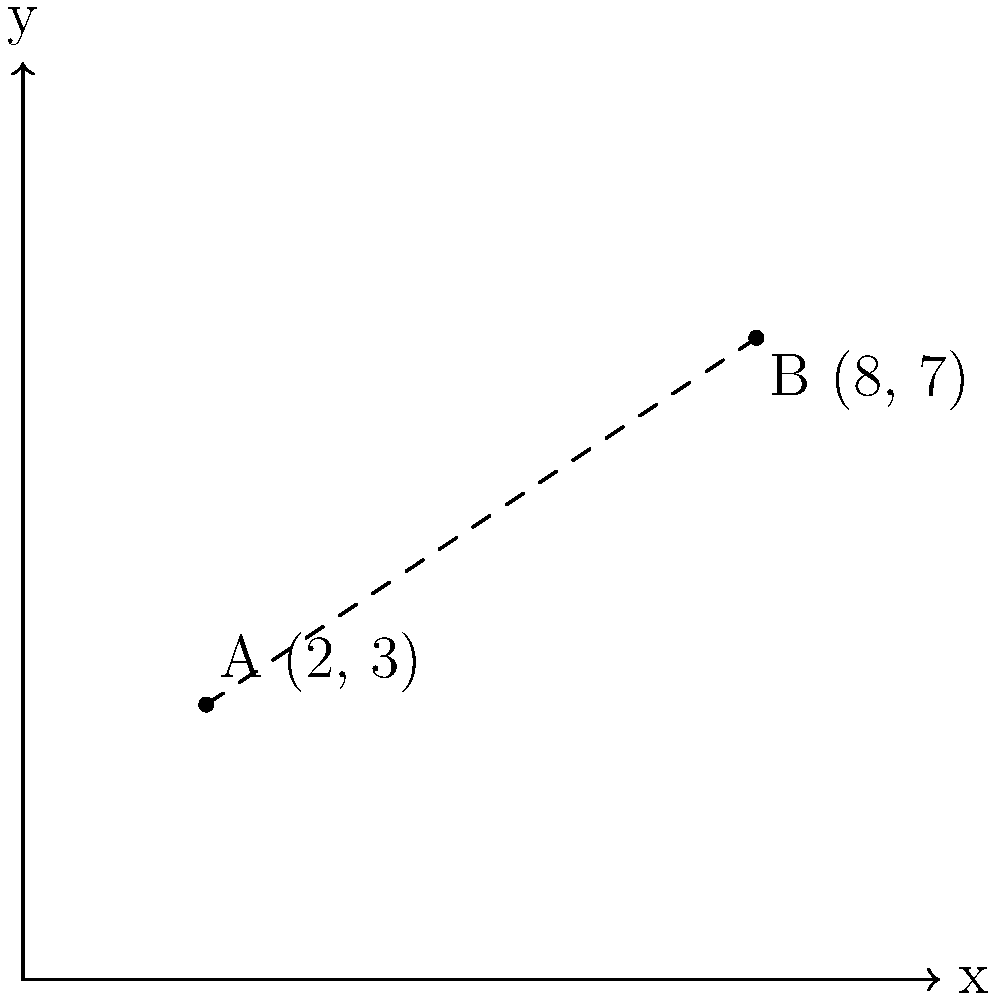As a logistician managing relief goods distribution, you need to calculate the distance between two distribution points on a map. Point A has coordinates (2, 3) and Point B has coordinates (8, 7). Using the distance formula, calculate the straight-line distance between these two points. Round your answer to two decimal places. To find the distance between two points given their coordinates, we can use the distance formula:

$$ d = \sqrt{(x_2 - x_1)^2 + (y_2 - y_1)^2} $$

Where $(x_1, y_1)$ are the coordinates of the first point and $(x_2, y_2)$ are the coordinates of the second point.

Given:
Point A: $(x_1, y_1) = (2, 3)$
Point B: $(x_2, y_2) = (8, 7)$

Step 1: Substitute the values into the formula.
$$ d = \sqrt{(8 - 2)^2 + (7 - 3)^2} $$

Step 2: Simplify the expressions inside the parentheses.
$$ d = \sqrt{6^2 + 4^2} $$

Step 3: Calculate the squares.
$$ d = \sqrt{36 + 16} $$

Step 4: Add the values under the square root.
$$ d = \sqrt{52} $$

Step 5: Calculate the square root and round to two decimal places.
$$ d \approx 7.21 $$

Therefore, the distance between the two distribution points is approximately 7.21 units on the map.
Answer: 7.21 units 